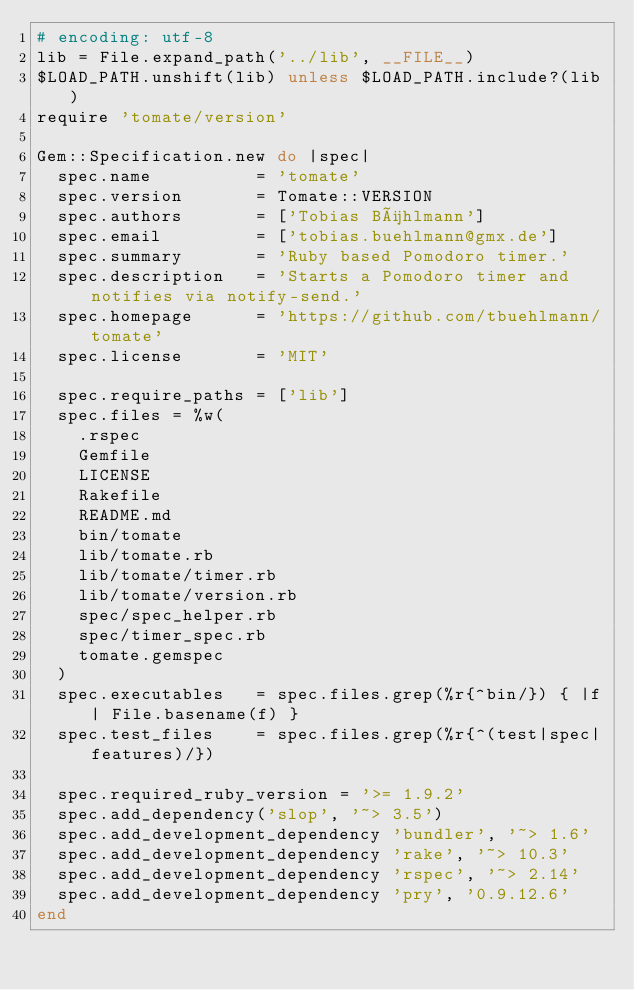<code> <loc_0><loc_0><loc_500><loc_500><_Ruby_># encoding: utf-8
lib = File.expand_path('../lib', __FILE__)
$LOAD_PATH.unshift(lib) unless $LOAD_PATH.include?(lib)
require 'tomate/version'

Gem::Specification.new do |spec|
  spec.name          = 'tomate'
  spec.version       = Tomate::VERSION
  spec.authors       = ['Tobias Bühlmann']
  spec.email         = ['tobias.buehlmann@gmx.de']
  spec.summary       = 'Ruby based Pomodoro timer.'
  spec.description   = 'Starts a Pomodoro timer and notifies via notify-send.'
  spec.homepage      = 'https://github.com/tbuehlmann/tomate'
  spec.license       = 'MIT'

  spec.require_paths = ['lib']
  spec.files = %w(
    .rspec
    Gemfile
    LICENSE
    Rakefile
    README.md
    bin/tomate
    lib/tomate.rb
    lib/tomate/timer.rb
    lib/tomate/version.rb
    spec/spec_helper.rb
    spec/timer_spec.rb
    tomate.gemspec
  )
  spec.executables   = spec.files.grep(%r{^bin/}) { |f| File.basename(f) }
  spec.test_files    = spec.files.grep(%r{^(test|spec|features)/})

  spec.required_ruby_version = '>= 1.9.2'
  spec.add_dependency('slop', '~> 3.5')
  spec.add_development_dependency 'bundler', '~> 1.6'
  spec.add_development_dependency 'rake', '~> 10.3'
  spec.add_development_dependency 'rspec', '~> 2.14'
  spec.add_development_dependency 'pry', '0.9.12.6'
end
</code> 